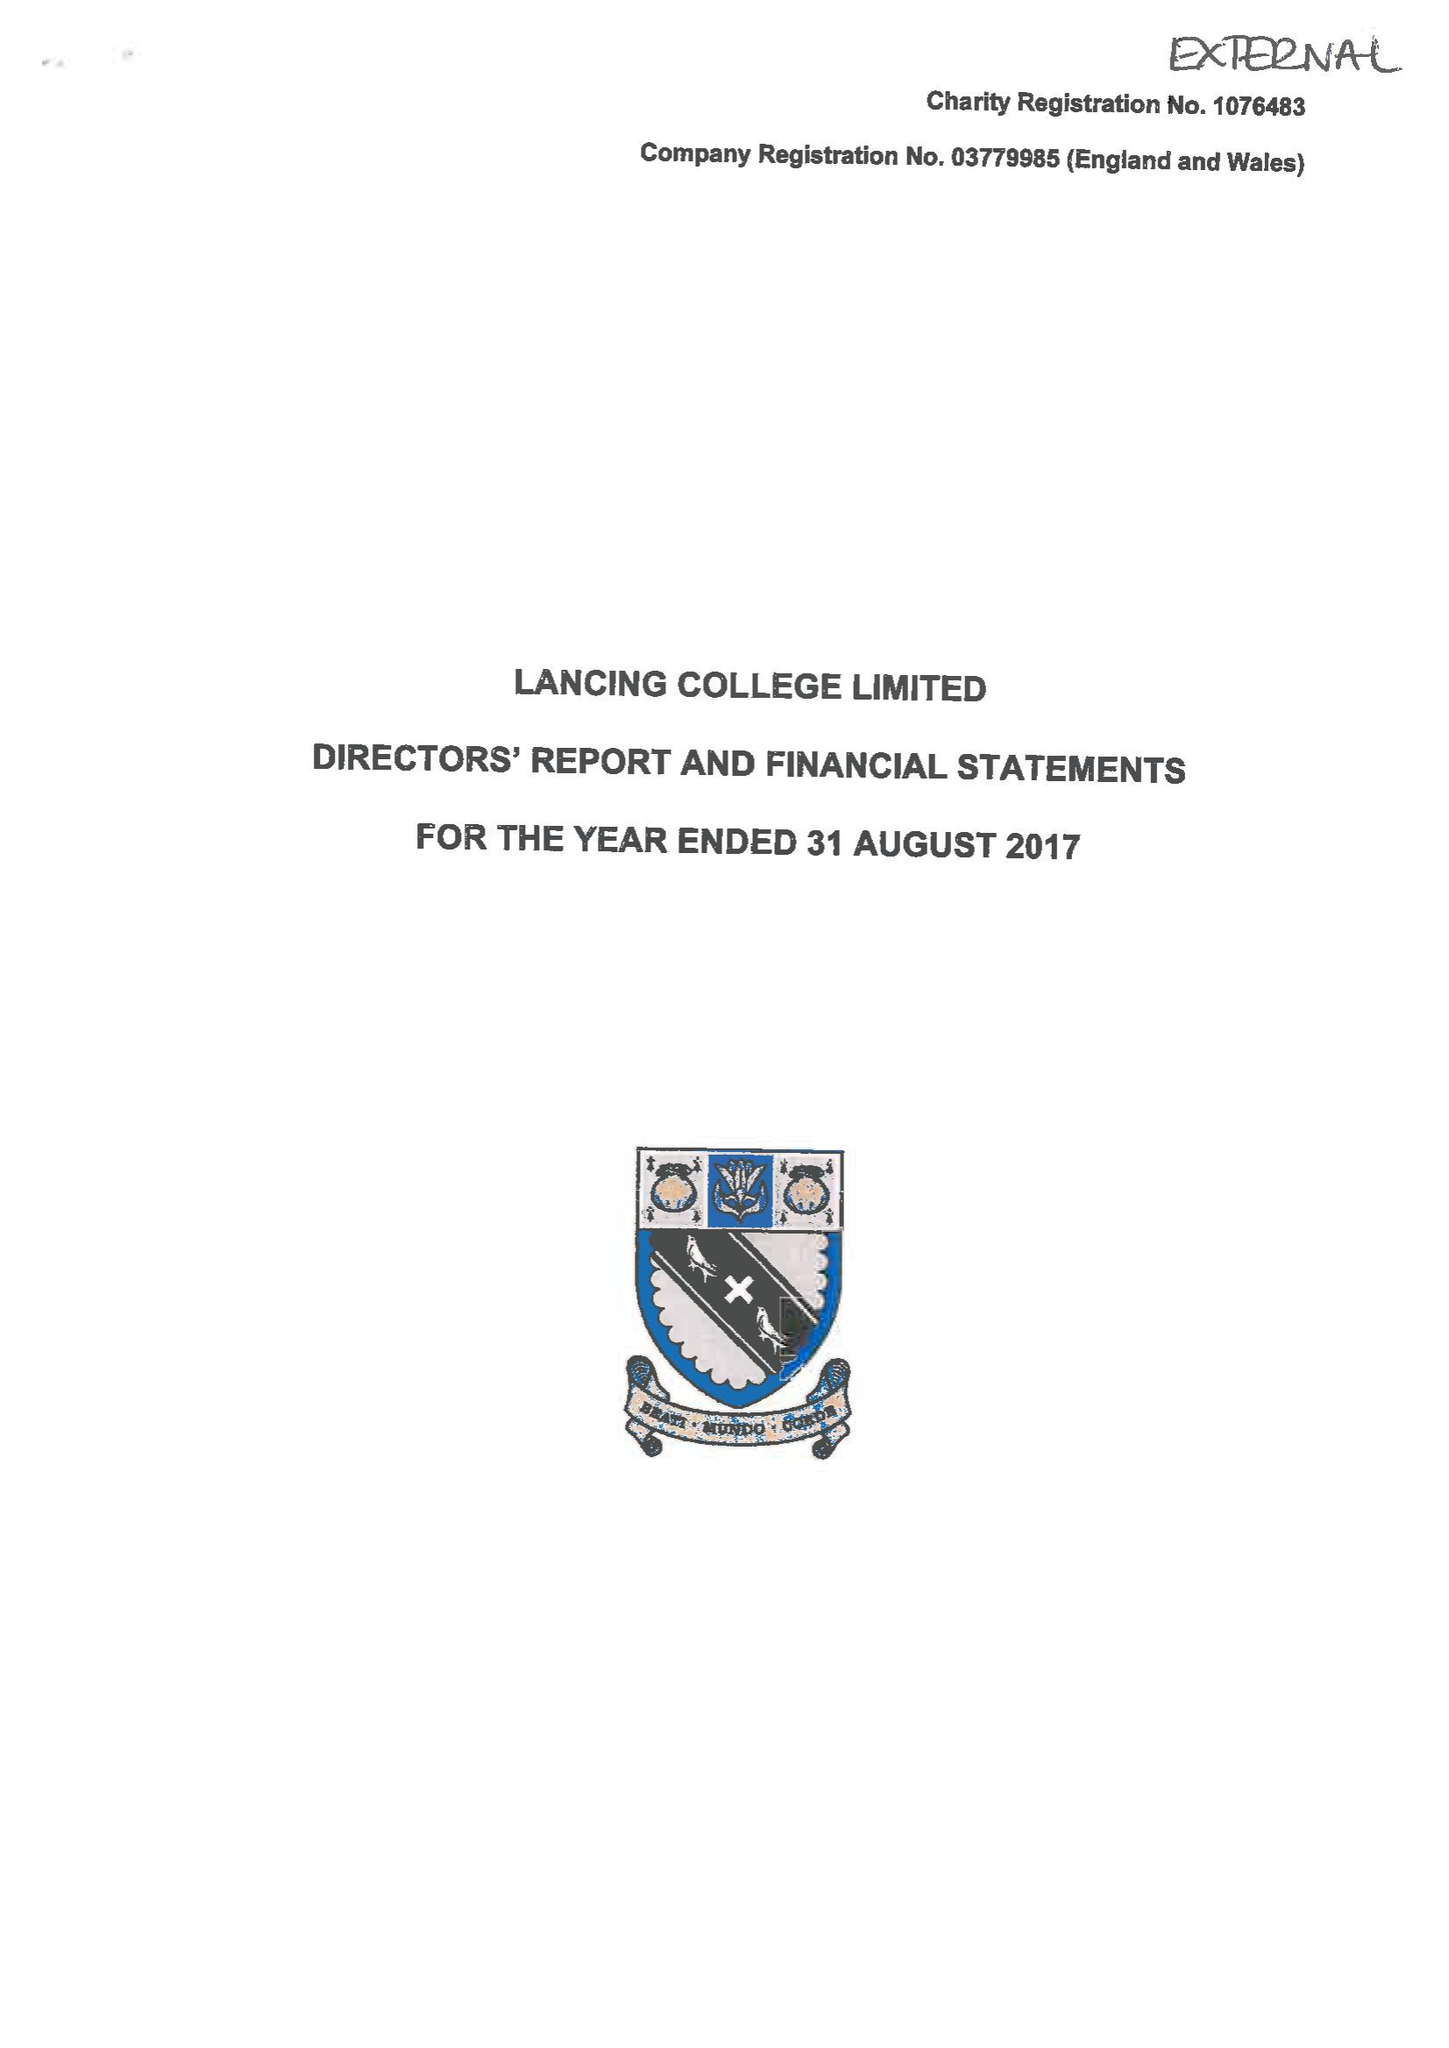What is the value for the report_date?
Answer the question using a single word or phrase. 2017-08-31 